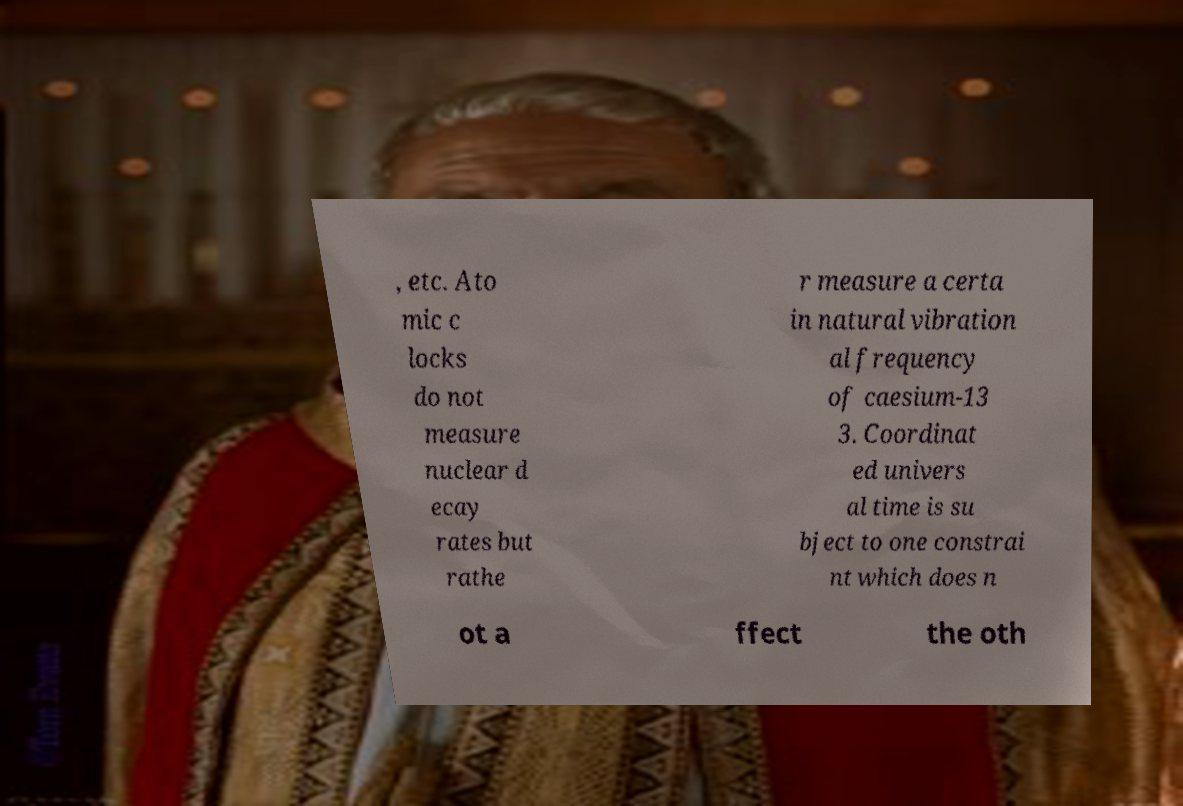There's text embedded in this image that I need extracted. Can you transcribe it verbatim? , etc. Ato mic c locks do not measure nuclear d ecay rates but rathe r measure a certa in natural vibration al frequency of caesium-13 3. Coordinat ed univers al time is su bject to one constrai nt which does n ot a ffect the oth 